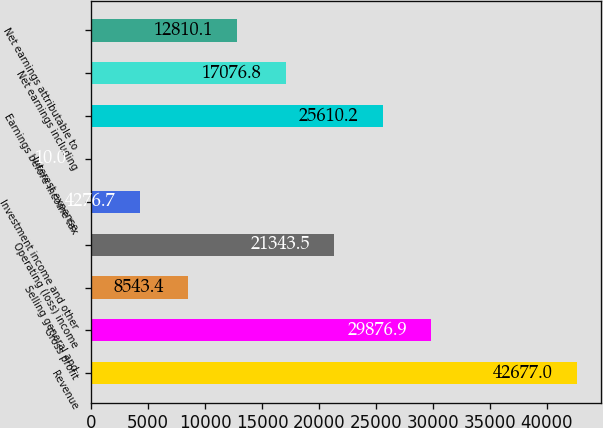Convert chart to OTSL. <chart><loc_0><loc_0><loc_500><loc_500><bar_chart><fcel>Revenue<fcel>Gross profit<fcel>Selling general and<fcel>Operating (loss) income<fcel>Investment income and other<fcel>Interest expense<fcel>Earnings before income tax<fcel>Net earnings including<fcel>Net earnings attributable to<nl><fcel>42677<fcel>29876.9<fcel>8543.4<fcel>21343.5<fcel>4276.7<fcel>10<fcel>25610.2<fcel>17076.8<fcel>12810.1<nl></chart> 